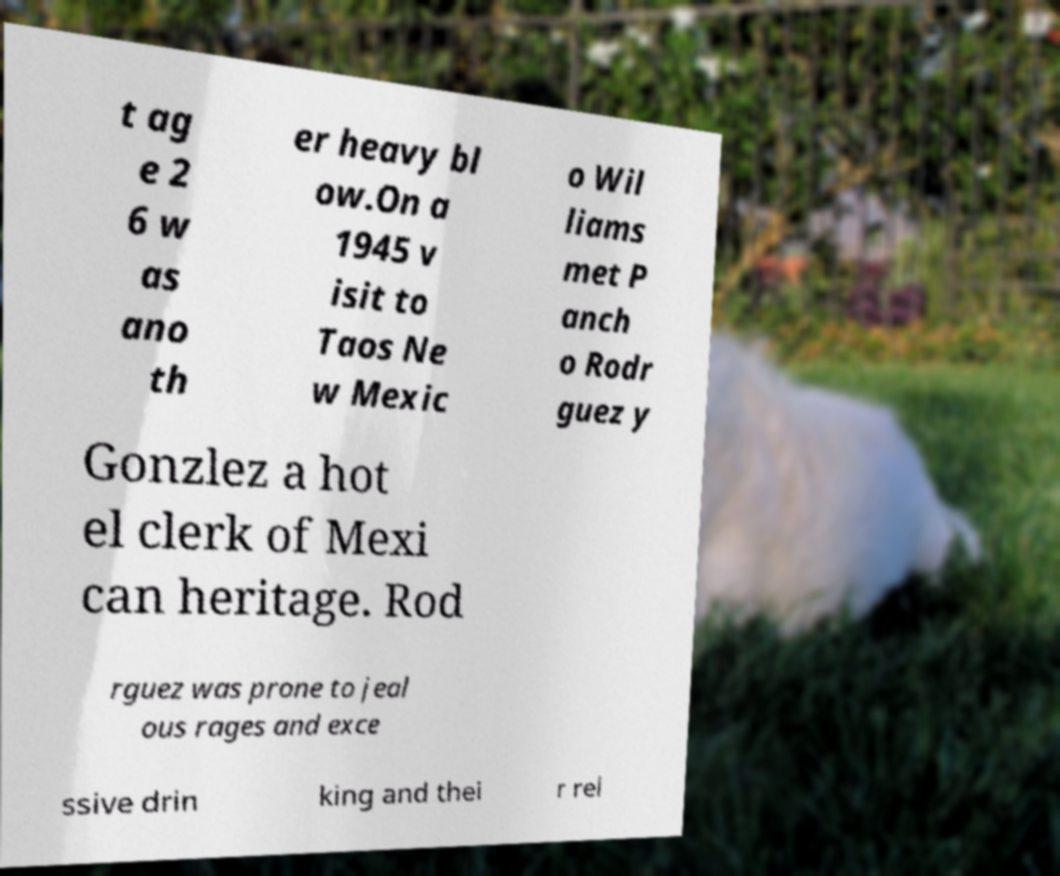For documentation purposes, I need the text within this image transcribed. Could you provide that? t ag e 2 6 w as ano th er heavy bl ow.On a 1945 v isit to Taos Ne w Mexic o Wil liams met P anch o Rodr guez y Gonzlez a hot el clerk of Mexi can heritage. Rod rguez was prone to jeal ous rages and exce ssive drin king and thei r rel 